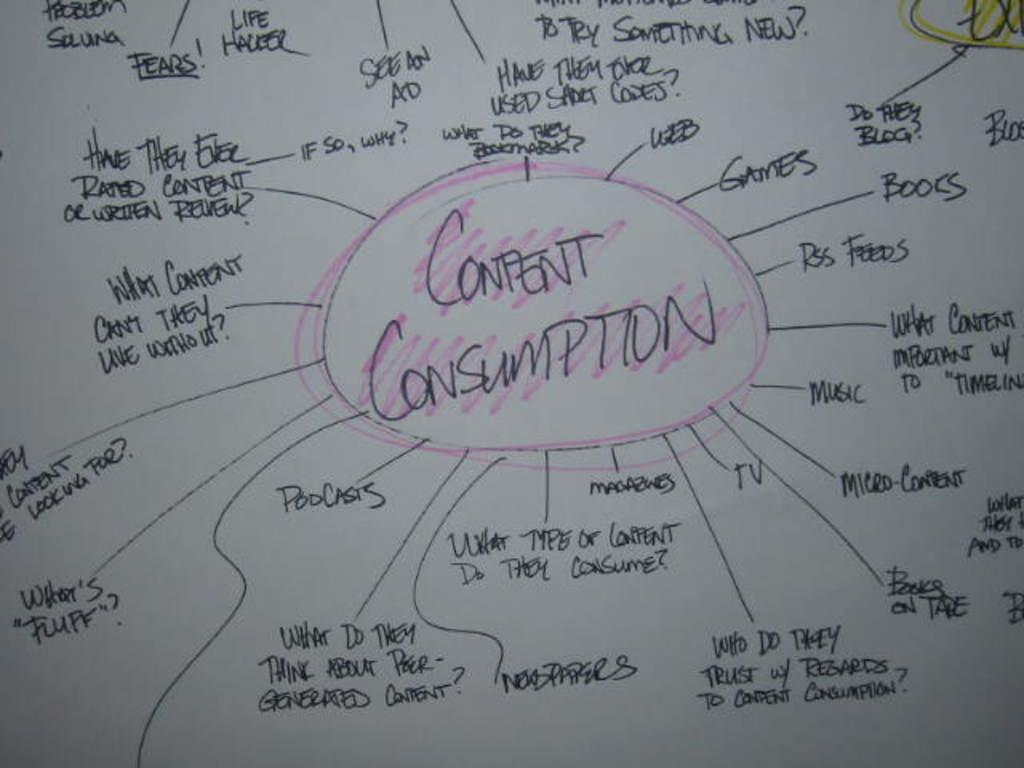<image>
Share a concise interpretation of the image provided. white board with lots of ideas on confent consumption 